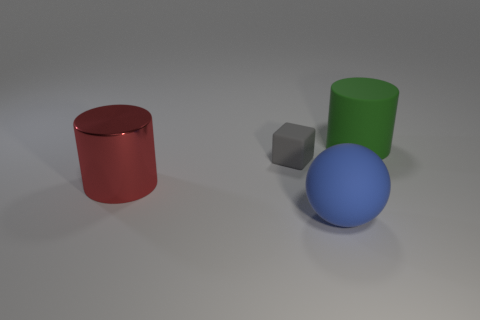There is a big ball that is the same material as the small block; what is its color?
Make the answer very short. Blue. Are there fewer small gray matte objects than small cyan metallic objects?
Make the answer very short. No. There is a big thing that is behind the small thing; is it the same shape as the large thing that is on the left side of the blue matte object?
Ensure brevity in your answer.  Yes. What number of things are either green matte cylinders or big blue rubber things?
Make the answer very short. 2. What is the color of the ball that is the same size as the metallic cylinder?
Your answer should be very brief. Blue. There is a cylinder that is behind the metal thing; how many cylinders are to the left of it?
Your response must be concise. 1. What number of objects are both behind the blue matte thing and left of the green rubber object?
Offer a very short reply. 2. What number of things are big cylinders that are behind the metal object or big cylinders in front of the large green cylinder?
Ensure brevity in your answer.  2. How many other objects are the same size as the gray matte block?
Offer a terse response. 0. What shape is the big object that is behind the large cylinder that is left of the gray cube?
Your response must be concise. Cylinder. 